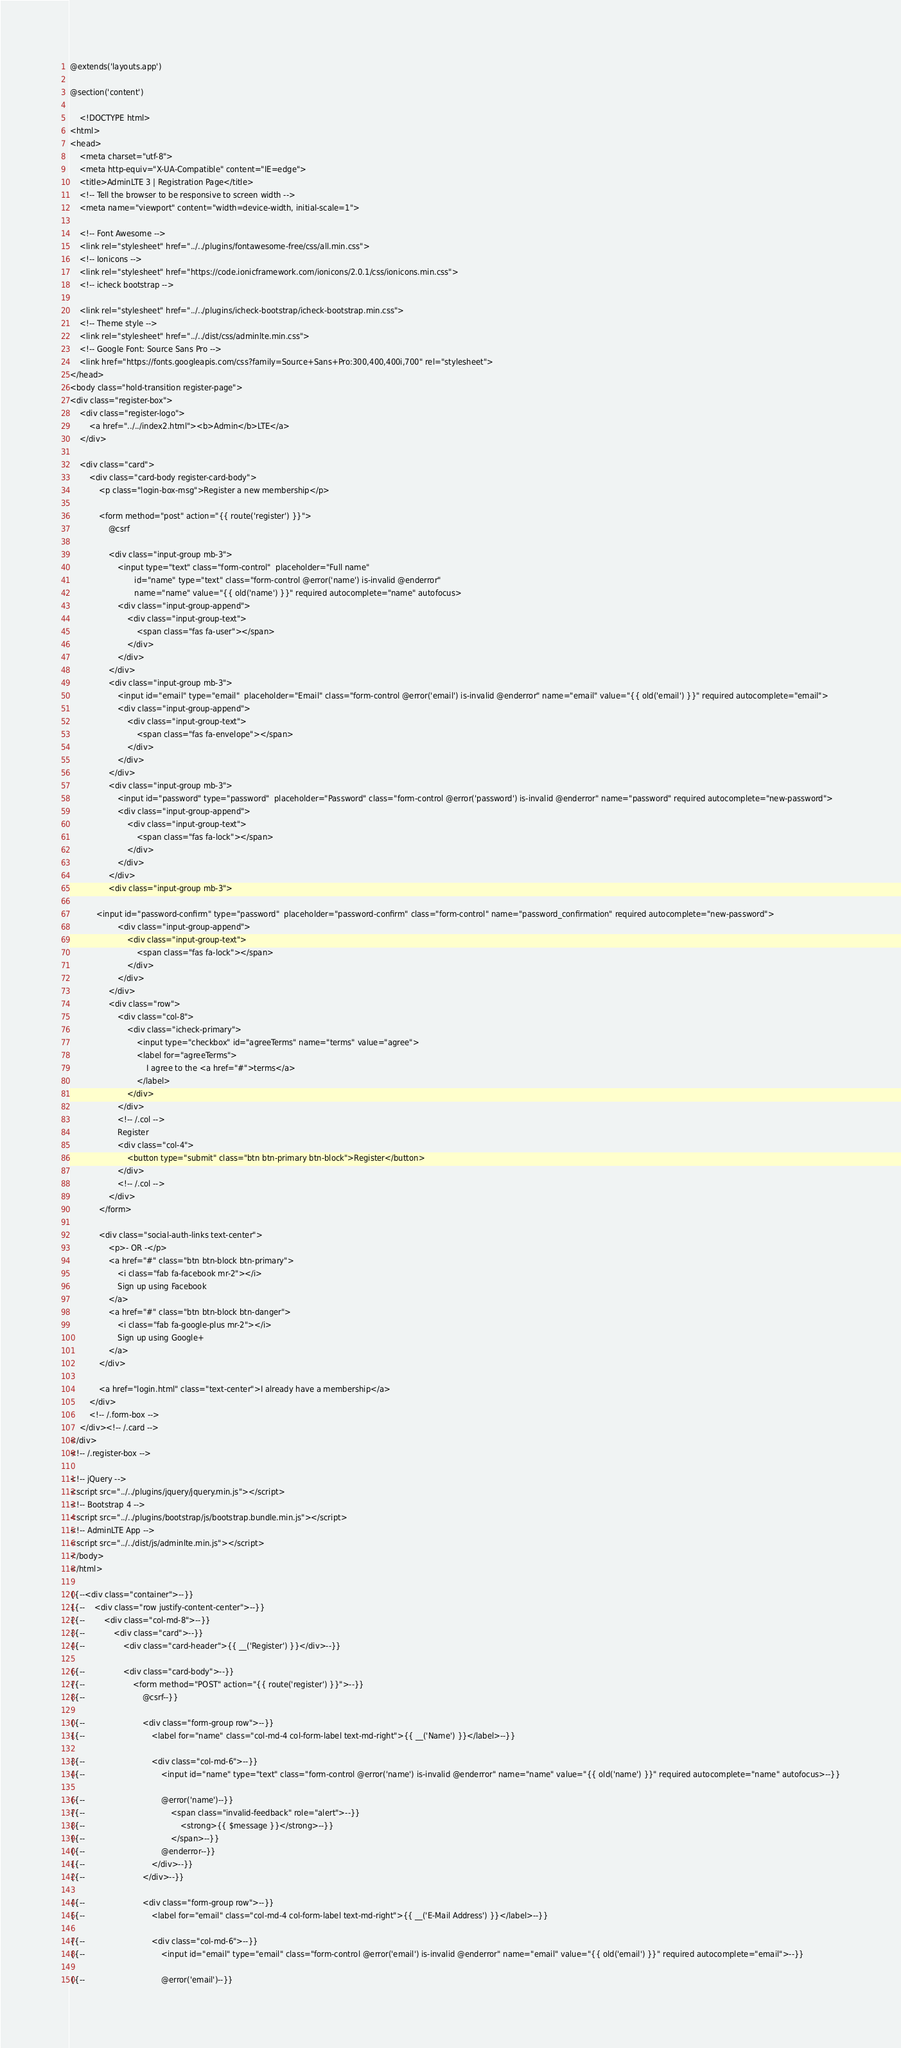Convert code to text. <code><loc_0><loc_0><loc_500><loc_500><_PHP_>@extends('layouts.app')

@section('content')

    <!DOCTYPE html>
<html>
<head>
    <meta charset="utf-8">
    <meta http-equiv="X-UA-Compatible" content="IE=edge">
    <title>AdminLTE 3 | Registration Page</title>
    <!-- Tell the browser to be responsive to screen width -->
    <meta name="viewport" content="width=device-width, initial-scale=1">

    <!-- Font Awesome -->
    <link rel="stylesheet" href="../../plugins/fontawesome-free/css/all.min.css">
    <!-- Ionicons -->
    <link rel="stylesheet" href="https://code.ionicframework.com/ionicons/2.0.1/css/ionicons.min.css">
    <!-- icheck bootstrap -->

    <link rel="stylesheet" href="../../plugins/icheck-bootstrap/icheck-bootstrap.min.css">
    <!-- Theme style -->
    <link rel="stylesheet" href="../../dist/css/adminlte.min.css">
    <!-- Google Font: Source Sans Pro -->
    <link href="https://fonts.googleapis.com/css?family=Source+Sans+Pro:300,400,400i,700" rel="stylesheet">
</head>
<body class="hold-transition register-page">
<div class="register-box">
    <div class="register-logo">
        <a href="../../index2.html"><b>Admin</b>LTE</a>
    </div>

    <div class="card">
        <div class="card-body register-card-body">
            <p class="login-box-msg">Register a new membership</p>

            <form method="post" action="{{ route('register') }}">
                @csrf

                <div class="input-group mb-3">
                    <input type="text" class="form-control"  placeholder="Full name"
                           id="name" type="text" class="form-control @error('name') is-invalid @enderror"
                           name="name" value="{{ old('name') }}" required autocomplete="name" autofocus>
                    <div class="input-group-append">
                        <div class="input-group-text">
                            <span class="fas fa-user"></span>
                        </div>
                    </div>
                </div>
                <div class="input-group mb-3">
                    <input id="email" type="email"  placeholder="Email" class="form-control @error('email') is-invalid @enderror" name="email" value="{{ old('email') }}" required autocomplete="email">
                    <div class="input-group-append">
                        <div class="input-group-text">
                            <span class="fas fa-envelope"></span>
                        </div>
                    </div>
                </div>
                <div class="input-group mb-3">
                    <input id="password" type="password"  placeholder="Password" class="form-control @error('password') is-invalid @enderror" name="password" required autocomplete="new-password">
                    <div class="input-group-append">
                        <div class="input-group-text">
                            <span class="fas fa-lock"></span>
                        </div>
                    </div>
                </div>
                <div class="input-group mb-3">

           <input id="password-confirm" type="password"  placeholder="password-confirm" class="form-control" name="password_confirmation" required autocomplete="new-password">
                    <div class="input-group-append">
                        <div class="input-group-text">
                            <span class="fas fa-lock"></span>
                        </div>
                    </div>
                </div>
                <div class="row">
                    <div class="col-8">
                        <div class="icheck-primary">
                            <input type="checkbox" id="agreeTerms" name="terms" value="agree">
                            <label for="agreeTerms">
                                I agree to the <a href="#">terms</a>
                            </label>
                        </div>
                    </div>
                    <!-- /.col -->
                    Register
                    <div class="col-4">
                        <button type="submit" class="btn btn-primary btn-block">Register</button>
                    </div>
                    <!-- /.col -->
                </div>
            </form>

            <div class="social-auth-links text-center">
                <p>- OR -</p>
                <a href="#" class="btn btn-block btn-primary">
                    <i class="fab fa-facebook mr-2"></i>
                    Sign up using Facebook
                </a>
                <a href="#" class="btn btn-block btn-danger">
                    <i class="fab fa-google-plus mr-2"></i>
                    Sign up using Google+
                </a>
            </div>

            <a href="login.html" class="text-center">I already have a membership</a>
        </div>
        <!-- /.form-box -->
    </div><!-- /.card -->
</div>
<!-- /.register-box -->

<!-- jQuery -->
<script src="../../plugins/jquery/jquery.min.js"></script>
<!-- Bootstrap 4 -->
<script src="../../plugins/bootstrap/js/bootstrap.bundle.min.js"></script>
<!-- AdminLTE App -->
<script src="../../dist/js/adminlte.min.js"></script>
</body>
</html>

{{--<div class="container">--}}
{{--    <div class="row justify-content-center">--}}
{{--        <div class="col-md-8">--}}
{{--            <div class="card">--}}
{{--                <div class="card-header">{{ __('Register') }}</div>--}}

{{--                <div class="card-body">--}}
{{--                    <form method="POST" action="{{ route('register') }}">--}}
{{--                        @csrf--}}

{{--                        <div class="form-group row">--}}
{{--                            <label for="name" class="col-md-4 col-form-label text-md-right">{{ __('Name') }}</label>--}}

{{--                            <div class="col-md-6">--}}
{{--                                <input id="name" type="text" class="form-control @error('name') is-invalid @enderror" name="name" value="{{ old('name') }}" required autocomplete="name" autofocus>--}}

{{--                                @error('name')--}}
{{--                                    <span class="invalid-feedback" role="alert">--}}
{{--                                        <strong>{{ $message }}</strong>--}}
{{--                                    </span>--}}
{{--                                @enderror--}}
{{--                            </div>--}}
{{--                        </div>--}}

{{--                        <div class="form-group row">--}}
{{--                            <label for="email" class="col-md-4 col-form-label text-md-right">{{ __('E-Mail Address') }}</label>--}}

{{--                            <div class="col-md-6">--}}
{{--                                <input id="email" type="email" class="form-control @error('email') is-invalid @enderror" name="email" value="{{ old('email') }}" required autocomplete="email">--}}

{{--                                @error('email')--}}</code> 